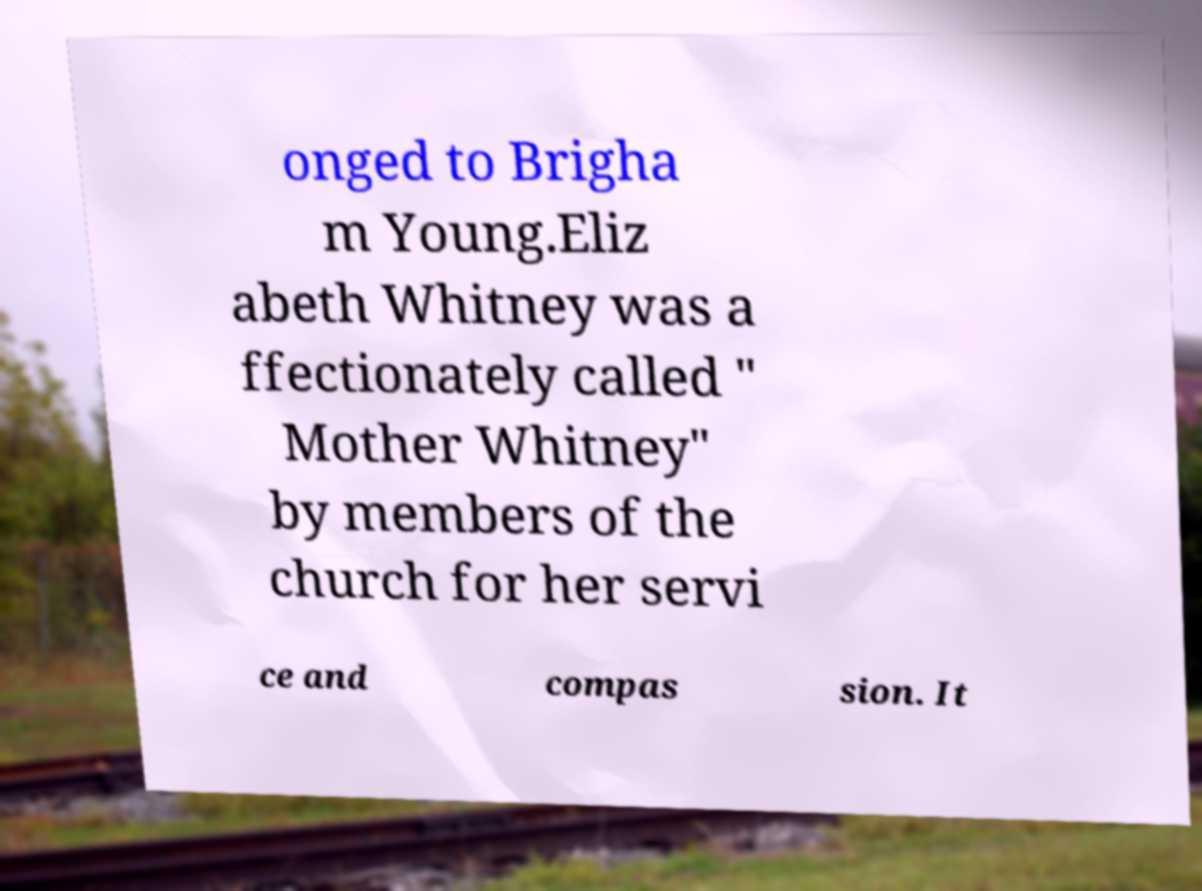Could you extract and type out the text from this image? onged to Brigha m Young.Eliz abeth Whitney was a ffectionately called " Mother Whitney" by members of the church for her servi ce and compas sion. It 